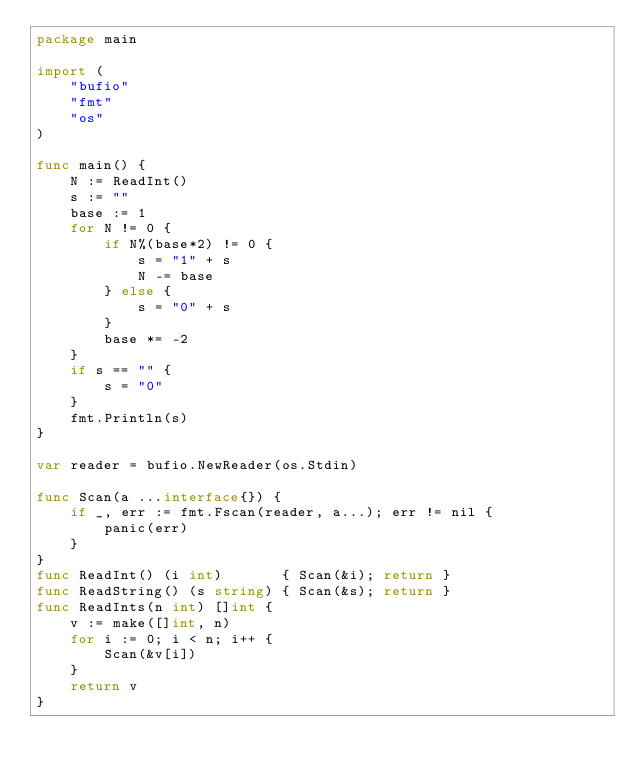Convert code to text. <code><loc_0><loc_0><loc_500><loc_500><_Go_>package main

import (
	"bufio"
	"fmt"
	"os"
)

func main() {
	N := ReadInt()
	s := ""
	base := 1
	for N != 0 {
		if N%(base*2) != 0 {
			s = "1" + s
			N -= base
		} else {
			s = "0" + s
		}
		base *= -2
	}
	if s == "" {
		s = "0"
	}
	fmt.Println(s)
}

var reader = bufio.NewReader(os.Stdin)

func Scan(a ...interface{}) {
	if _, err := fmt.Fscan(reader, a...); err != nil {
		panic(err)
	}
}
func ReadInt() (i int)       { Scan(&i); return }
func ReadString() (s string) { Scan(&s); return }
func ReadInts(n int) []int {
	v := make([]int, n)
	for i := 0; i < n; i++ {
		Scan(&v[i])
	}
	return v
}
</code> 